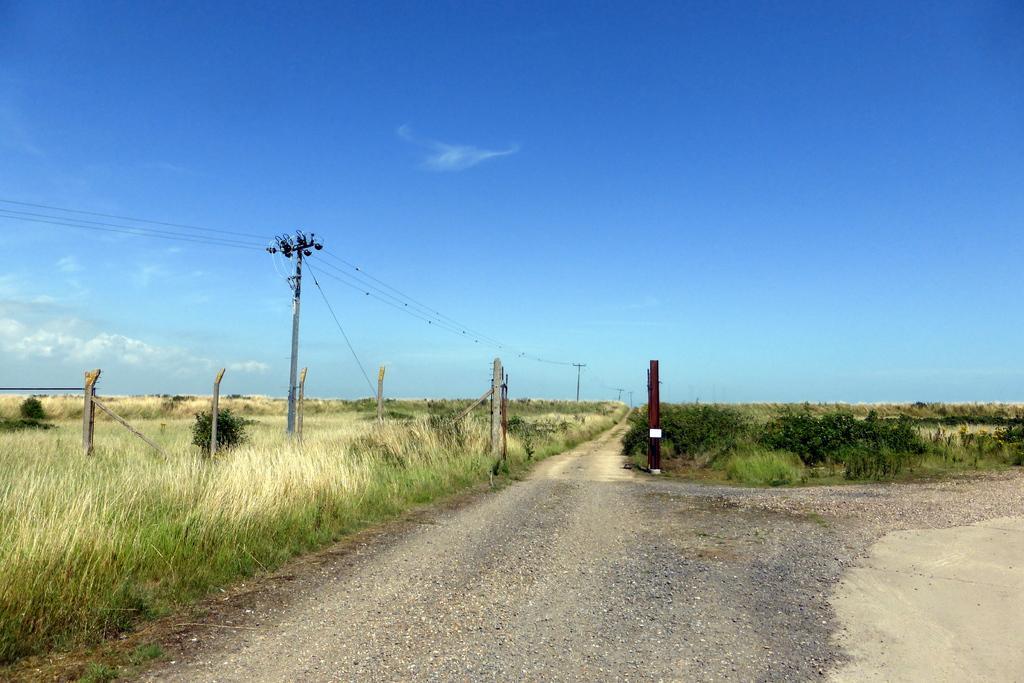Please provide a concise description of this image. In this image I can see a road and crop, poles, power line cables and grass at the top I can see the sky and grass visible in the middle. 